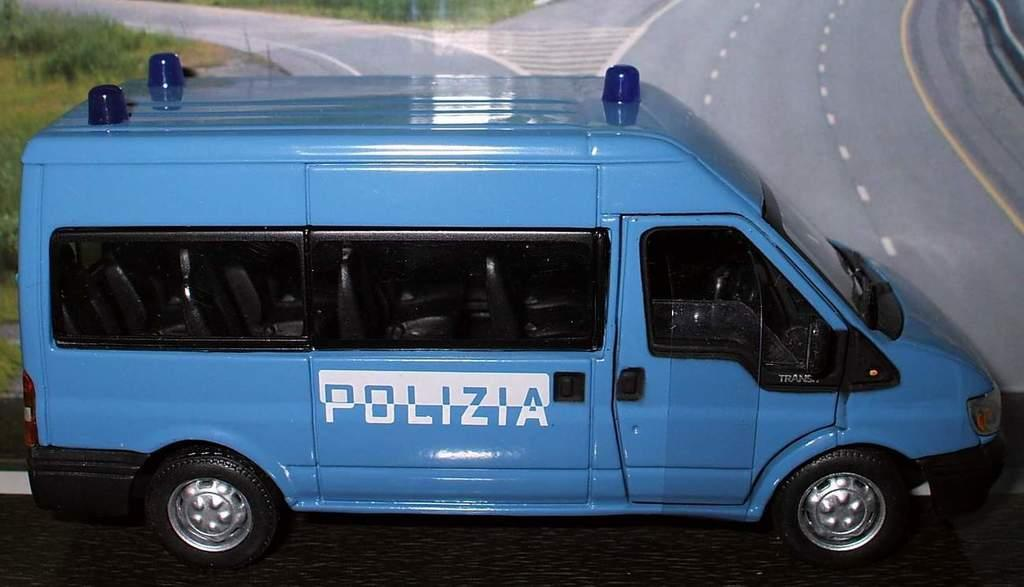What type of toy is present in the image? There is a toy vehicle in the image. What can be seen behind the toy vehicle? There is a poster visible behind the toy vehicle. What type of shoe is visible in the image? There is no shoe present in the image. Can you tell me what the receipt says for the toy vehicle purchase? There is no receipt present in the image. 